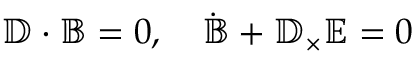Convert formula to latex. <formula><loc_0><loc_0><loc_500><loc_500>\mathbb { D } \cdot \mathbb { B } = 0 , \quad \dot { \mathbb { B } } + \mathbb { D } _ { \times } \mathbb { E } = 0</formula> 